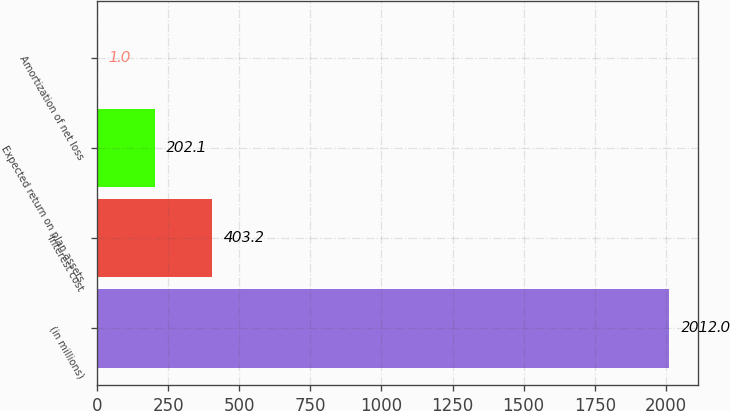Convert chart to OTSL. <chart><loc_0><loc_0><loc_500><loc_500><bar_chart><fcel>(in millions)<fcel>Interest cost<fcel>Expected return on plan assets<fcel>Amortization of net loss<nl><fcel>2012<fcel>403.2<fcel>202.1<fcel>1<nl></chart> 